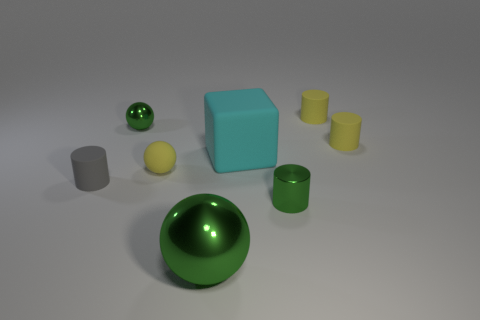Considering the different objects in the image, can you describe the lighting direction and its effects? The lighting in the image appears to be coming from the upper left-hand side, given the shadows cast towards the bottom right. This creates a soft gradient of light across the surfaces, highlighting the shapes and textures of the objects and enhancing their three-dimensional appearance. 